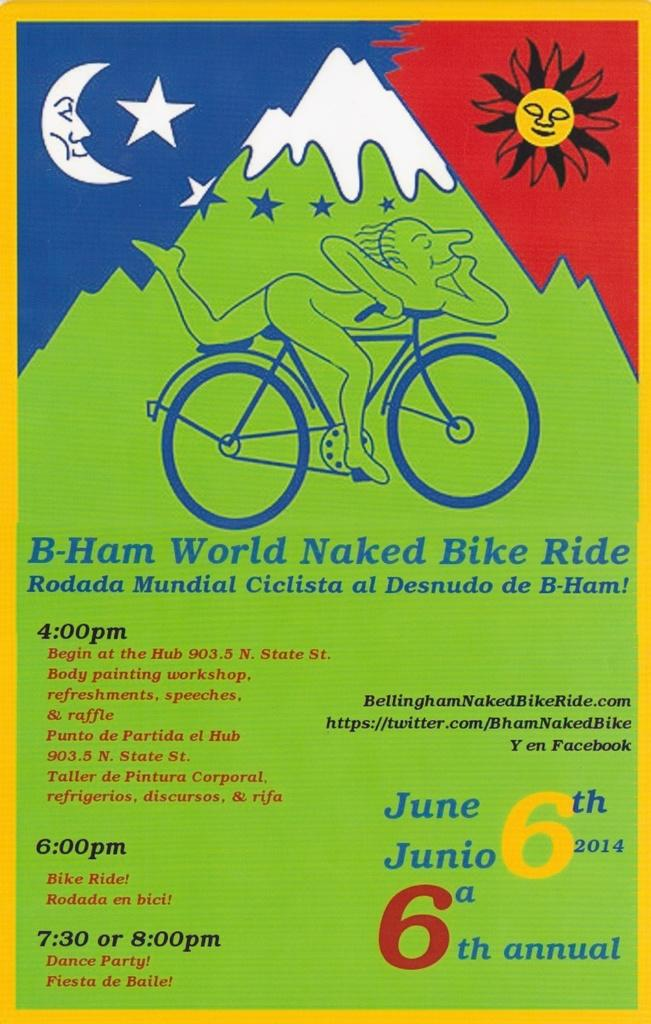<image>
Describe the image concisely. a green red and blue poster for the World Naked Bike Ride 